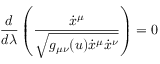Convert formula to latex. <formula><loc_0><loc_0><loc_500><loc_500>\frac { d } { d \lambda } \left ( \frac { \dot { x } ^ { \mu } } { \sqrt { g _ { \mu \nu } ( u ) \dot { x } ^ { \mu } \dot { x } ^ { \nu } } } \right ) = 0</formula> 